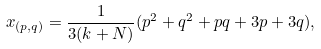Convert formula to latex. <formula><loc_0><loc_0><loc_500><loc_500>x _ { ( p , q ) } = \frac { 1 } { 3 ( k + N ) } ( p ^ { 2 } + q ^ { 2 } + p q + 3 p + 3 q ) ,</formula> 